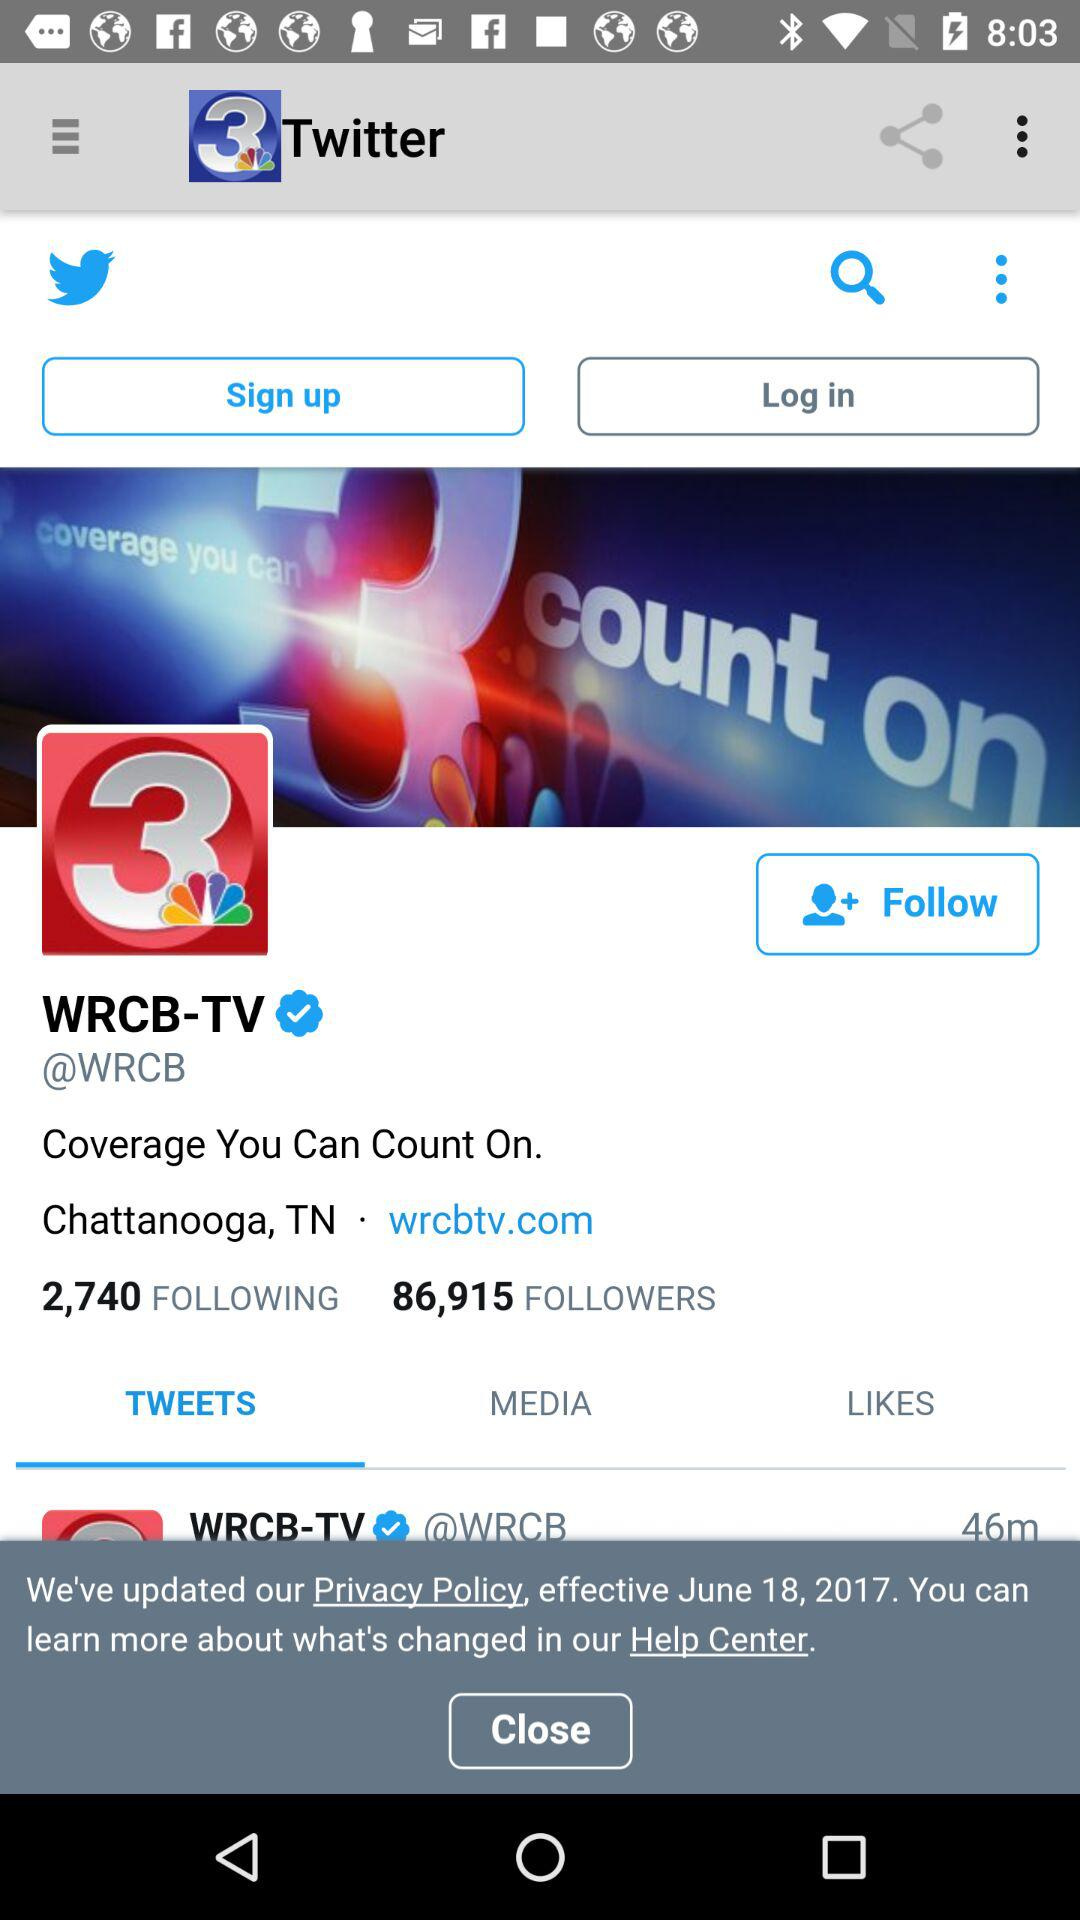How many followers does WRCB-TV have?
Answer the question using a single word or phrase. 86,915 